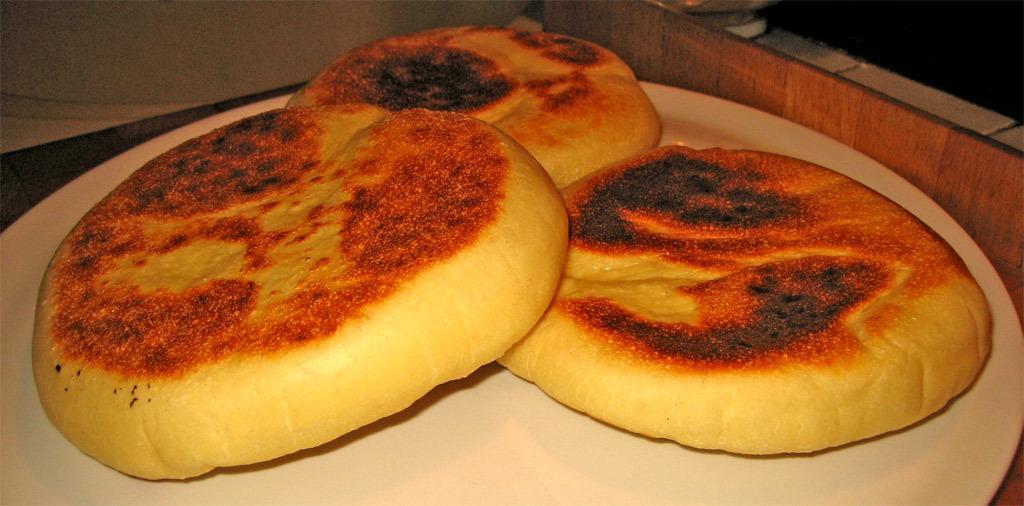Could you give a brief overview of what you see in this image? The picture consists of breeds which are in round shape, they are placed in a plate. The plate is on the table. At the top there is a wooden object. 